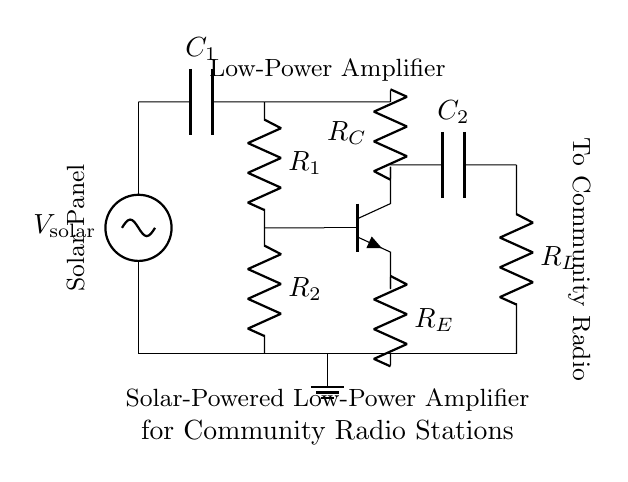What is the purpose of the solar panel in this circuit? The solar panel provides the necessary power supply for the amplifier circuit, indicated by the voltage source labeled V_solar.
Answer: Power supply What components are used in the amplifier circuit? The circuit diagram includes a solar panel, capacitors, resistors, a transistor, and a load resistor. Each component is labeled appropriately in the diagram.
Answer: Solar panel, capacitors, resistors, transistor, load resistor What type of transistor is used in this amplifier? The circuit diagram shows an NPN transistor, which is represented by the npn notation in the drawing.
Answer: NPN How many capacitors are in the circuit? There are two capacitors indicated in the diagram, labeled C_1 and C_2, connecting the solar panel to the transistor and the output to the load respectively.
Answer: Two What is the function of the emitter resistor? The emitter resistor (R_E) is used to stabilize the operating point of the transistor and improve linearity in amplification, which is crucial for maintaining audio quality in radio applications.
Answer: Stabilization What is the relationship between R_1 and R_2? R_1 and R_2 are biasing resistors that set the base current and determine the operating point of the transistor, establishing the proper biasing for the NPN transistor to amplify signals efficiently.
Answer: Biasing What is the output of the amplifier connected to? The output (after the capacitor C_2) is connected to a resistor (R_L), which serves as the load for the amplified audio signals directed toward the community radio.
Answer: Load resistor 